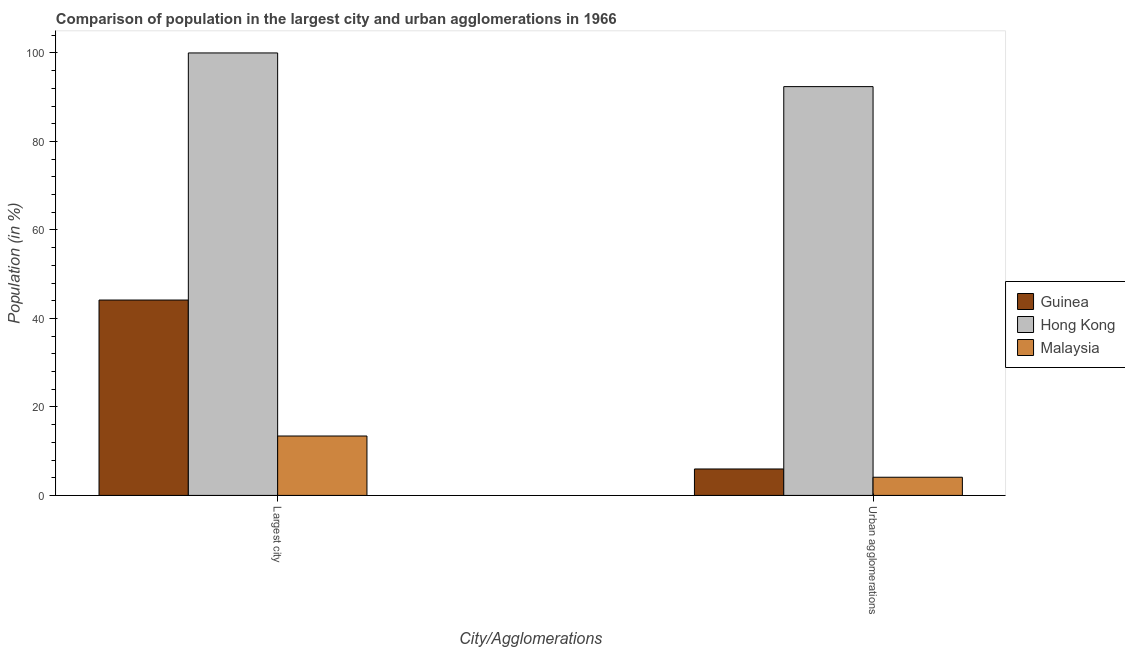How many different coloured bars are there?
Make the answer very short. 3. Are the number of bars on each tick of the X-axis equal?
Your answer should be compact. Yes. How many bars are there on the 1st tick from the left?
Provide a succinct answer. 3. How many bars are there on the 2nd tick from the right?
Keep it short and to the point. 3. What is the label of the 2nd group of bars from the left?
Your response must be concise. Urban agglomerations. What is the population in the largest city in Guinea?
Your answer should be very brief. 44.16. Across all countries, what is the maximum population in urban agglomerations?
Your answer should be very brief. 92.39. Across all countries, what is the minimum population in urban agglomerations?
Provide a short and direct response. 4.11. In which country was the population in urban agglomerations maximum?
Keep it short and to the point. Hong Kong. In which country was the population in urban agglomerations minimum?
Your answer should be compact. Malaysia. What is the total population in the largest city in the graph?
Your answer should be compact. 157.59. What is the difference between the population in the largest city in Guinea and that in Hong Kong?
Provide a short and direct response. -55.84. What is the difference between the population in urban agglomerations in Hong Kong and the population in the largest city in Guinea?
Give a very brief answer. 48.23. What is the average population in urban agglomerations per country?
Provide a succinct answer. 34.16. What is the difference between the population in urban agglomerations and population in the largest city in Malaysia?
Your response must be concise. -9.32. In how many countries, is the population in the largest city greater than 64 %?
Give a very brief answer. 1. What is the ratio of the population in urban agglomerations in Malaysia to that in Hong Kong?
Your answer should be compact. 0.04. Is the population in urban agglomerations in Malaysia less than that in Hong Kong?
Provide a succinct answer. Yes. In how many countries, is the population in the largest city greater than the average population in the largest city taken over all countries?
Offer a terse response. 1. What does the 3rd bar from the left in Urban agglomerations represents?
Provide a succinct answer. Malaysia. What does the 3rd bar from the right in Urban agglomerations represents?
Make the answer very short. Guinea. What is the difference between two consecutive major ticks on the Y-axis?
Offer a terse response. 20. Are the values on the major ticks of Y-axis written in scientific E-notation?
Offer a terse response. No. Does the graph contain grids?
Provide a succinct answer. No. How are the legend labels stacked?
Offer a terse response. Vertical. What is the title of the graph?
Offer a very short reply. Comparison of population in the largest city and urban agglomerations in 1966. Does "Small states" appear as one of the legend labels in the graph?
Provide a succinct answer. No. What is the label or title of the X-axis?
Offer a terse response. City/Agglomerations. What is the Population (in %) of Guinea in Largest city?
Ensure brevity in your answer.  44.16. What is the Population (in %) in Malaysia in Largest city?
Your answer should be very brief. 13.43. What is the Population (in %) of Guinea in Urban agglomerations?
Your response must be concise. 5.98. What is the Population (in %) in Hong Kong in Urban agglomerations?
Give a very brief answer. 92.39. What is the Population (in %) in Malaysia in Urban agglomerations?
Provide a succinct answer. 4.11. Across all City/Agglomerations, what is the maximum Population (in %) of Guinea?
Offer a terse response. 44.16. Across all City/Agglomerations, what is the maximum Population (in %) of Malaysia?
Your answer should be compact. 13.43. Across all City/Agglomerations, what is the minimum Population (in %) in Guinea?
Your response must be concise. 5.98. Across all City/Agglomerations, what is the minimum Population (in %) in Hong Kong?
Provide a short and direct response. 92.39. Across all City/Agglomerations, what is the minimum Population (in %) in Malaysia?
Provide a short and direct response. 4.11. What is the total Population (in %) in Guinea in the graph?
Make the answer very short. 50.13. What is the total Population (in %) of Hong Kong in the graph?
Your answer should be very brief. 192.39. What is the total Population (in %) in Malaysia in the graph?
Keep it short and to the point. 17.54. What is the difference between the Population (in %) of Guinea in Largest city and that in Urban agglomerations?
Offer a very short reply. 38.18. What is the difference between the Population (in %) in Hong Kong in Largest city and that in Urban agglomerations?
Keep it short and to the point. 7.61. What is the difference between the Population (in %) in Malaysia in Largest city and that in Urban agglomerations?
Provide a short and direct response. 9.32. What is the difference between the Population (in %) in Guinea in Largest city and the Population (in %) in Hong Kong in Urban agglomerations?
Provide a short and direct response. -48.23. What is the difference between the Population (in %) in Guinea in Largest city and the Population (in %) in Malaysia in Urban agglomerations?
Your response must be concise. 40.05. What is the difference between the Population (in %) of Hong Kong in Largest city and the Population (in %) of Malaysia in Urban agglomerations?
Your answer should be compact. 95.89. What is the average Population (in %) of Guinea per City/Agglomerations?
Offer a very short reply. 25.07. What is the average Population (in %) in Hong Kong per City/Agglomerations?
Give a very brief answer. 96.2. What is the average Population (in %) in Malaysia per City/Agglomerations?
Make the answer very short. 8.77. What is the difference between the Population (in %) in Guinea and Population (in %) in Hong Kong in Largest city?
Offer a terse response. -55.84. What is the difference between the Population (in %) in Guinea and Population (in %) in Malaysia in Largest city?
Offer a terse response. 30.73. What is the difference between the Population (in %) of Hong Kong and Population (in %) of Malaysia in Largest city?
Offer a very short reply. 86.57. What is the difference between the Population (in %) in Guinea and Population (in %) in Hong Kong in Urban agglomerations?
Give a very brief answer. -86.41. What is the difference between the Population (in %) in Guinea and Population (in %) in Malaysia in Urban agglomerations?
Offer a very short reply. 1.87. What is the difference between the Population (in %) of Hong Kong and Population (in %) of Malaysia in Urban agglomerations?
Ensure brevity in your answer.  88.28. What is the ratio of the Population (in %) of Guinea in Largest city to that in Urban agglomerations?
Make the answer very short. 7.39. What is the ratio of the Population (in %) of Hong Kong in Largest city to that in Urban agglomerations?
Keep it short and to the point. 1.08. What is the ratio of the Population (in %) of Malaysia in Largest city to that in Urban agglomerations?
Ensure brevity in your answer.  3.27. What is the difference between the highest and the second highest Population (in %) of Guinea?
Make the answer very short. 38.18. What is the difference between the highest and the second highest Population (in %) of Hong Kong?
Provide a short and direct response. 7.61. What is the difference between the highest and the second highest Population (in %) in Malaysia?
Ensure brevity in your answer.  9.32. What is the difference between the highest and the lowest Population (in %) in Guinea?
Provide a short and direct response. 38.18. What is the difference between the highest and the lowest Population (in %) in Hong Kong?
Keep it short and to the point. 7.61. What is the difference between the highest and the lowest Population (in %) of Malaysia?
Provide a succinct answer. 9.32. 